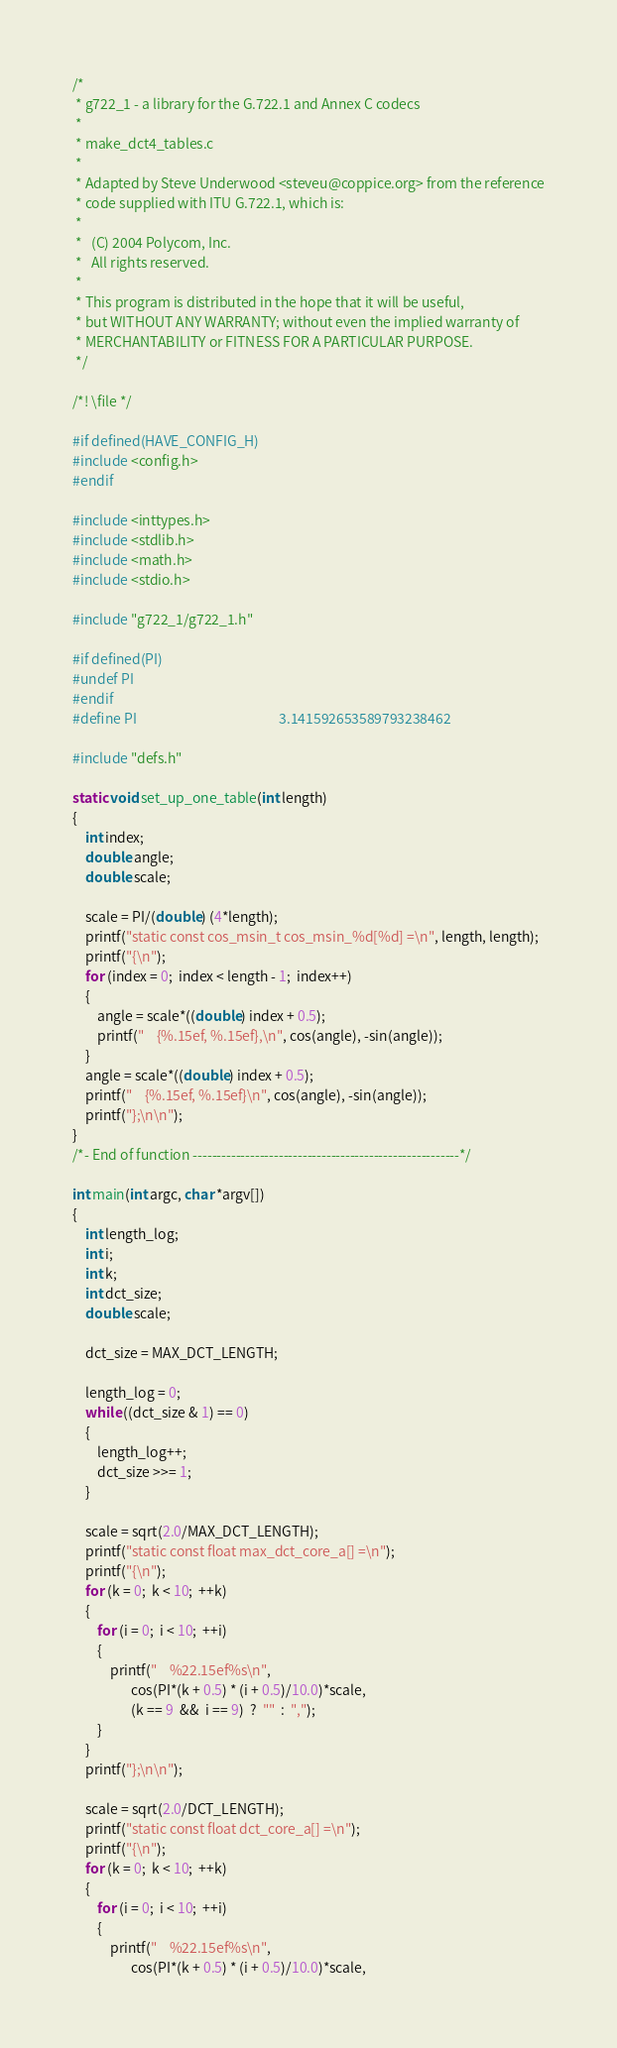Convert code to text. <code><loc_0><loc_0><loc_500><loc_500><_C_>/*
 * g722_1 - a library for the G.722.1 and Annex C codecs
 *
 * make_dct4_tables.c
 *
 * Adapted by Steve Underwood <steveu@coppice.org> from the reference
 * code supplied with ITU G.722.1, which is:
 *
 *   (C) 2004 Polycom, Inc.
 *   All rights reserved.
 *
 * This program is distributed in the hope that it will be useful,
 * but WITHOUT ANY WARRANTY; without even the implied warranty of
 * MERCHANTABILITY or FITNESS FOR A PARTICULAR PURPOSE.
 */

/*! \file */

#if defined(HAVE_CONFIG_H)
#include <config.h>
#endif

#include <inttypes.h>
#include <stdlib.h>
#include <math.h>
#include <stdio.h>

#include "g722_1/g722_1.h"

#if defined(PI)
#undef PI
#endif
#define PI                                              3.141592653589793238462

#include "defs.h"

static void set_up_one_table(int length)
{
    int index;
    double angle;
    double scale;

    scale = PI/(double) (4*length);
    printf("static const cos_msin_t cos_msin_%d[%d] =\n", length, length);
    printf("{\n");
    for (index = 0;  index < length - 1;  index++)
    {
        angle = scale*((double) index + 0.5);
        printf("    {%.15ef, %.15ef},\n", cos(angle), -sin(angle));
    }
    angle = scale*((double) index + 0.5);
    printf("    {%.15ef, %.15ef}\n", cos(angle), -sin(angle));
    printf("};\n\n");
}
/*- End of function --------------------------------------------------------*/

int main(int argc, char *argv[])
{
    int length_log;
    int i;
    int k;
    int dct_size;
    double scale;

    dct_size = MAX_DCT_LENGTH;

    length_log = 0;
    while ((dct_size & 1) == 0)
    {
        length_log++;
        dct_size >>= 1;
    }

    scale = sqrt(2.0/MAX_DCT_LENGTH);
    printf("static const float max_dct_core_a[] =\n");
    printf("{\n");
    for (k = 0;  k < 10;  ++k)
    {
        for (i = 0;  i < 10;  ++i)
        {
            printf("    %22.15ef%s\n",
                   cos(PI*(k + 0.5) * (i + 0.5)/10.0)*scale,
                   (k == 9  &&  i == 9)  ?  ""  :  ",");
        }
    }
    printf("};\n\n");

    scale = sqrt(2.0/DCT_LENGTH);
    printf("static const float dct_core_a[] =\n");
    printf("{\n");
    for (k = 0;  k < 10;  ++k)
    {
        for (i = 0;  i < 10;  ++i)
        {
            printf("    %22.15ef%s\n",
                   cos(PI*(k + 0.5) * (i + 0.5)/10.0)*scale,</code> 